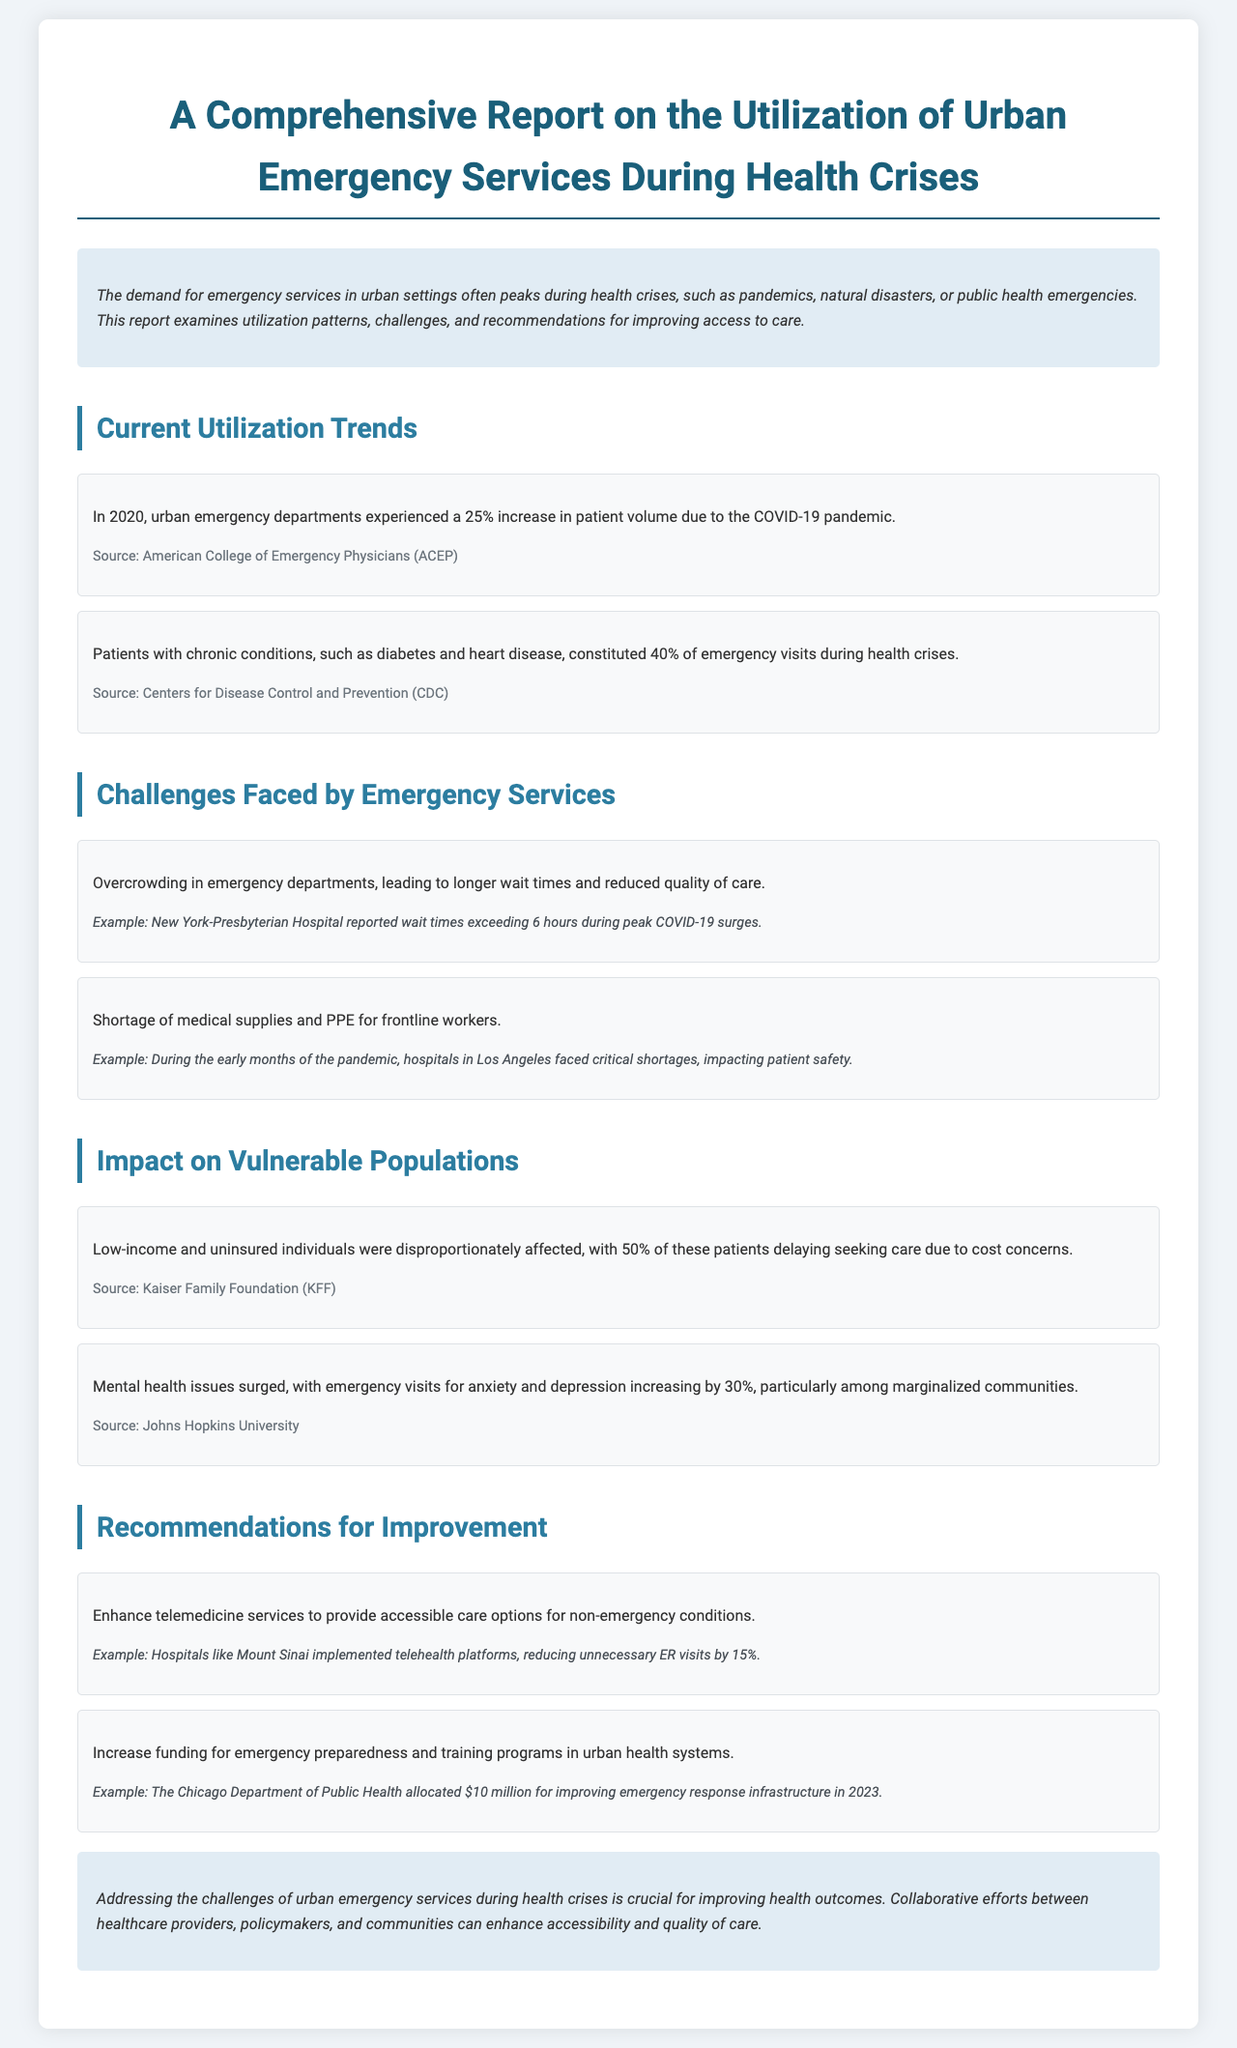What was the percentage increase in patient volume in 2020? The report states that urban emergency departments experienced a 25% increase in patient volume due to the COVID-19 pandemic.
Answer: 25% What percentage of emergency visits were patients with chronic conditions? According to the report, patients with chronic conditions constituted 40% of emergency visits during health crises.
Answer: 40% What is a key recommendation for improving emergency services? The report suggests enhancing telemedicine services to provide accessible care options for non-emergency conditions.
Answer: Enhance telemedicine services How long did patients wait at New York-Presbyterian Hospital during peak COVID-19 surges? The example given mentions that wait times exceeded 6 hours during peak COVID-19 surges.
Answer: 6 hours What percentage of low-income individuals delayed seeking care due to cost concerns? The report notes that 50% of low-income and uninsured individuals delayed seeking care due to cost concerns.
Answer: 50% What was the increase in emergency visits for anxiety and depression? The report states that emergency visits for anxiety and depression increased by 30%, particularly among marginalized communities.
Answer: 30% How much funding did the Chicago Department of Public Health allocate for improving emergency response infrastructure in 2023? The report mentions that the Chicago Department of Public Health allocated $10 million for improving emergency response infrastructure in 2023.
Answer: $10 million Which source reported that overcrowding in emergency departments affects quality of care? The report includes examples and statistics sourced from the American College of Emergency Physicians (ACEP) and the Centers for Disease Control and Prevention (CDC), noting overcrowding as a major issue.
Answer: ACEP, CDC What underlying issue significantly affected mental health during health crises? The report indicates that mental health issues surged, particularly among marginalized communities, due to the health crises.
Answer: Surge in mental health issues 